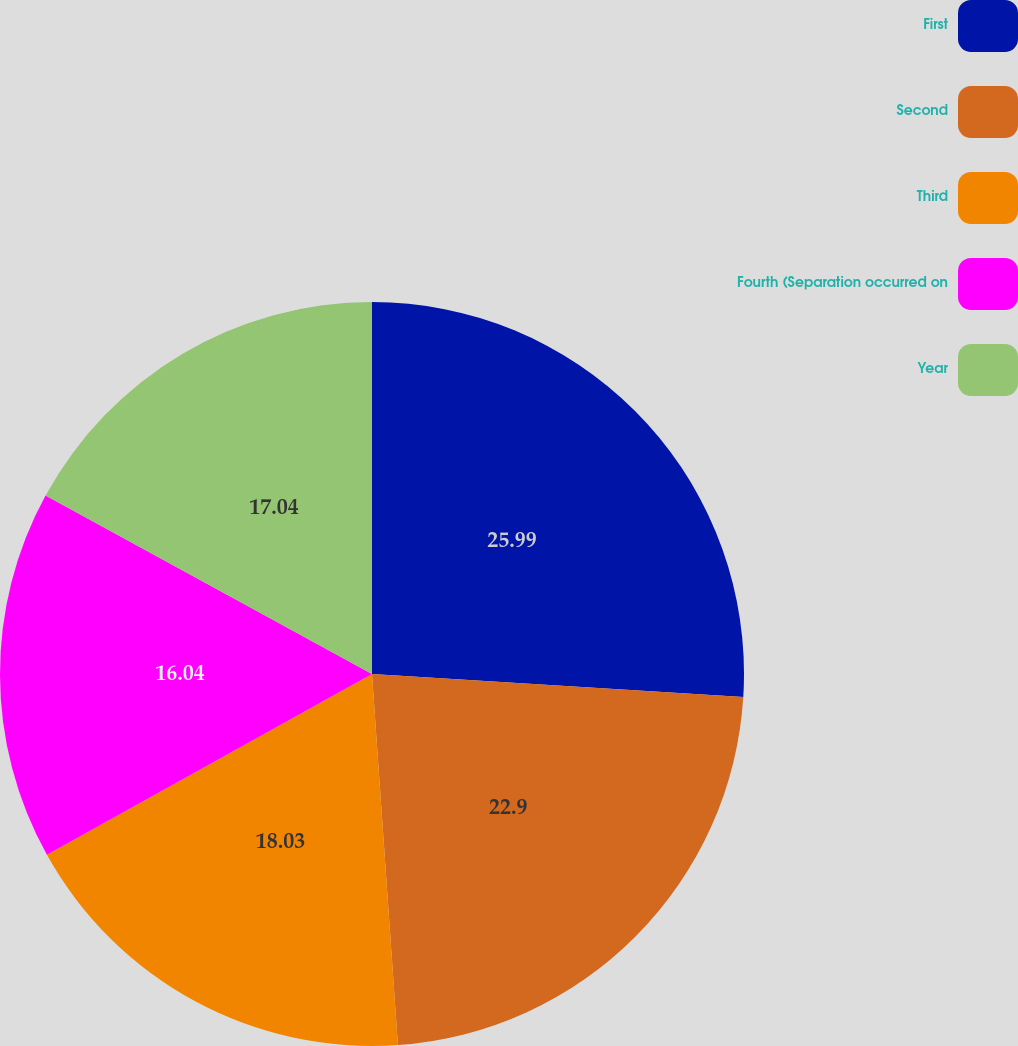<chart> <loc_0><loc_0><loc_500><loc_500><pie_chart><fcel>First<fcel>Second<fcel>Third<fcel>Fourth (Separation occurred on<fcel>Year<nl><fcel>25.99%<fcel>22.9%<fcel>18.03%<fcel>16.04%<fcel>17.04%<nl></chart> 